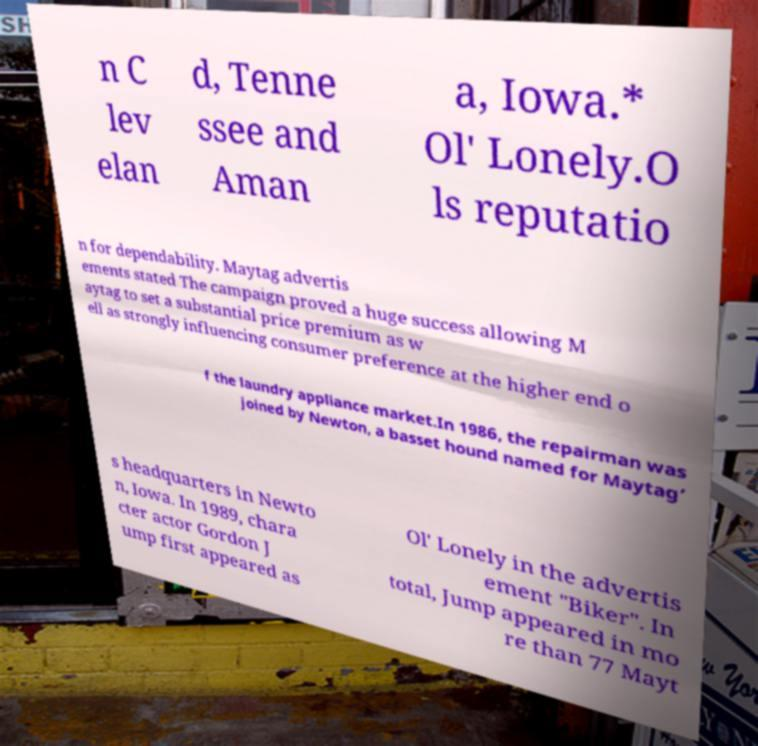Could you assist in decoding the text presented in this image and type it out clearly? n C lev elan d, Tenne ssee and Aman a, Iowa.* Ol' Lonely.O ls reputatio n for dependability. Maytag advertis ements stated The campaign proved a huge success allowing M aytag to set a substantial price premium as w ell as strongly influencing consumer preference at the higher end o f the laundry appliance market.In 1986, the repairman was joined by Newton, a basset hound named for Maytag’ s headquarters in Newto n, Iowa. In 1989, chara cter actor Gordon J ump first appeared as Ol' Lonely in the advertis ement "Biker". In total, Jump appeared in mo re than 77 Mayt 